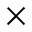Convert formula to latex. <formula><loc_0><loc_0><loc_500><loc_500>\times</formula> 